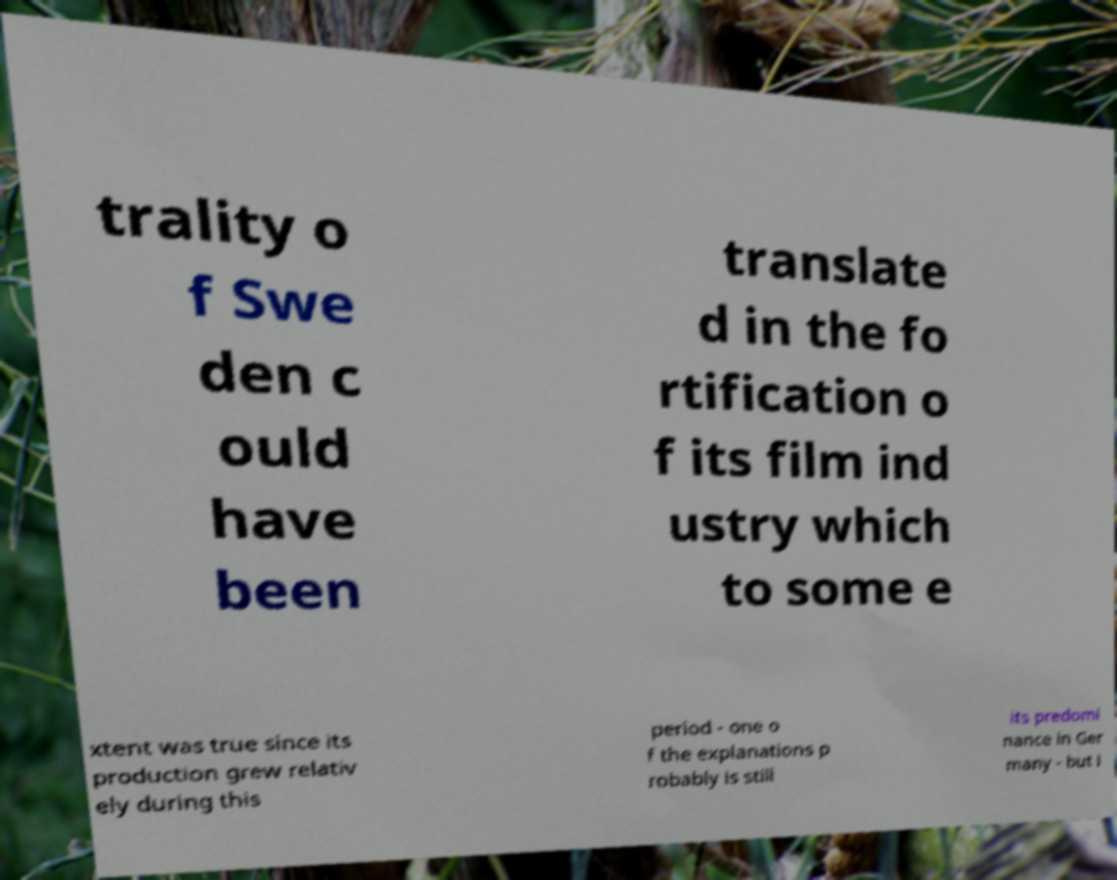Could you extract and type out the text from this image? trality o f Swe den c ould have been translate d in the fo rtification o f its film ind ustry which to some e xtent was true since its production grew relativ ely during this period - one o f the explanations p robably is still its predomi nance in Ger many - but i 